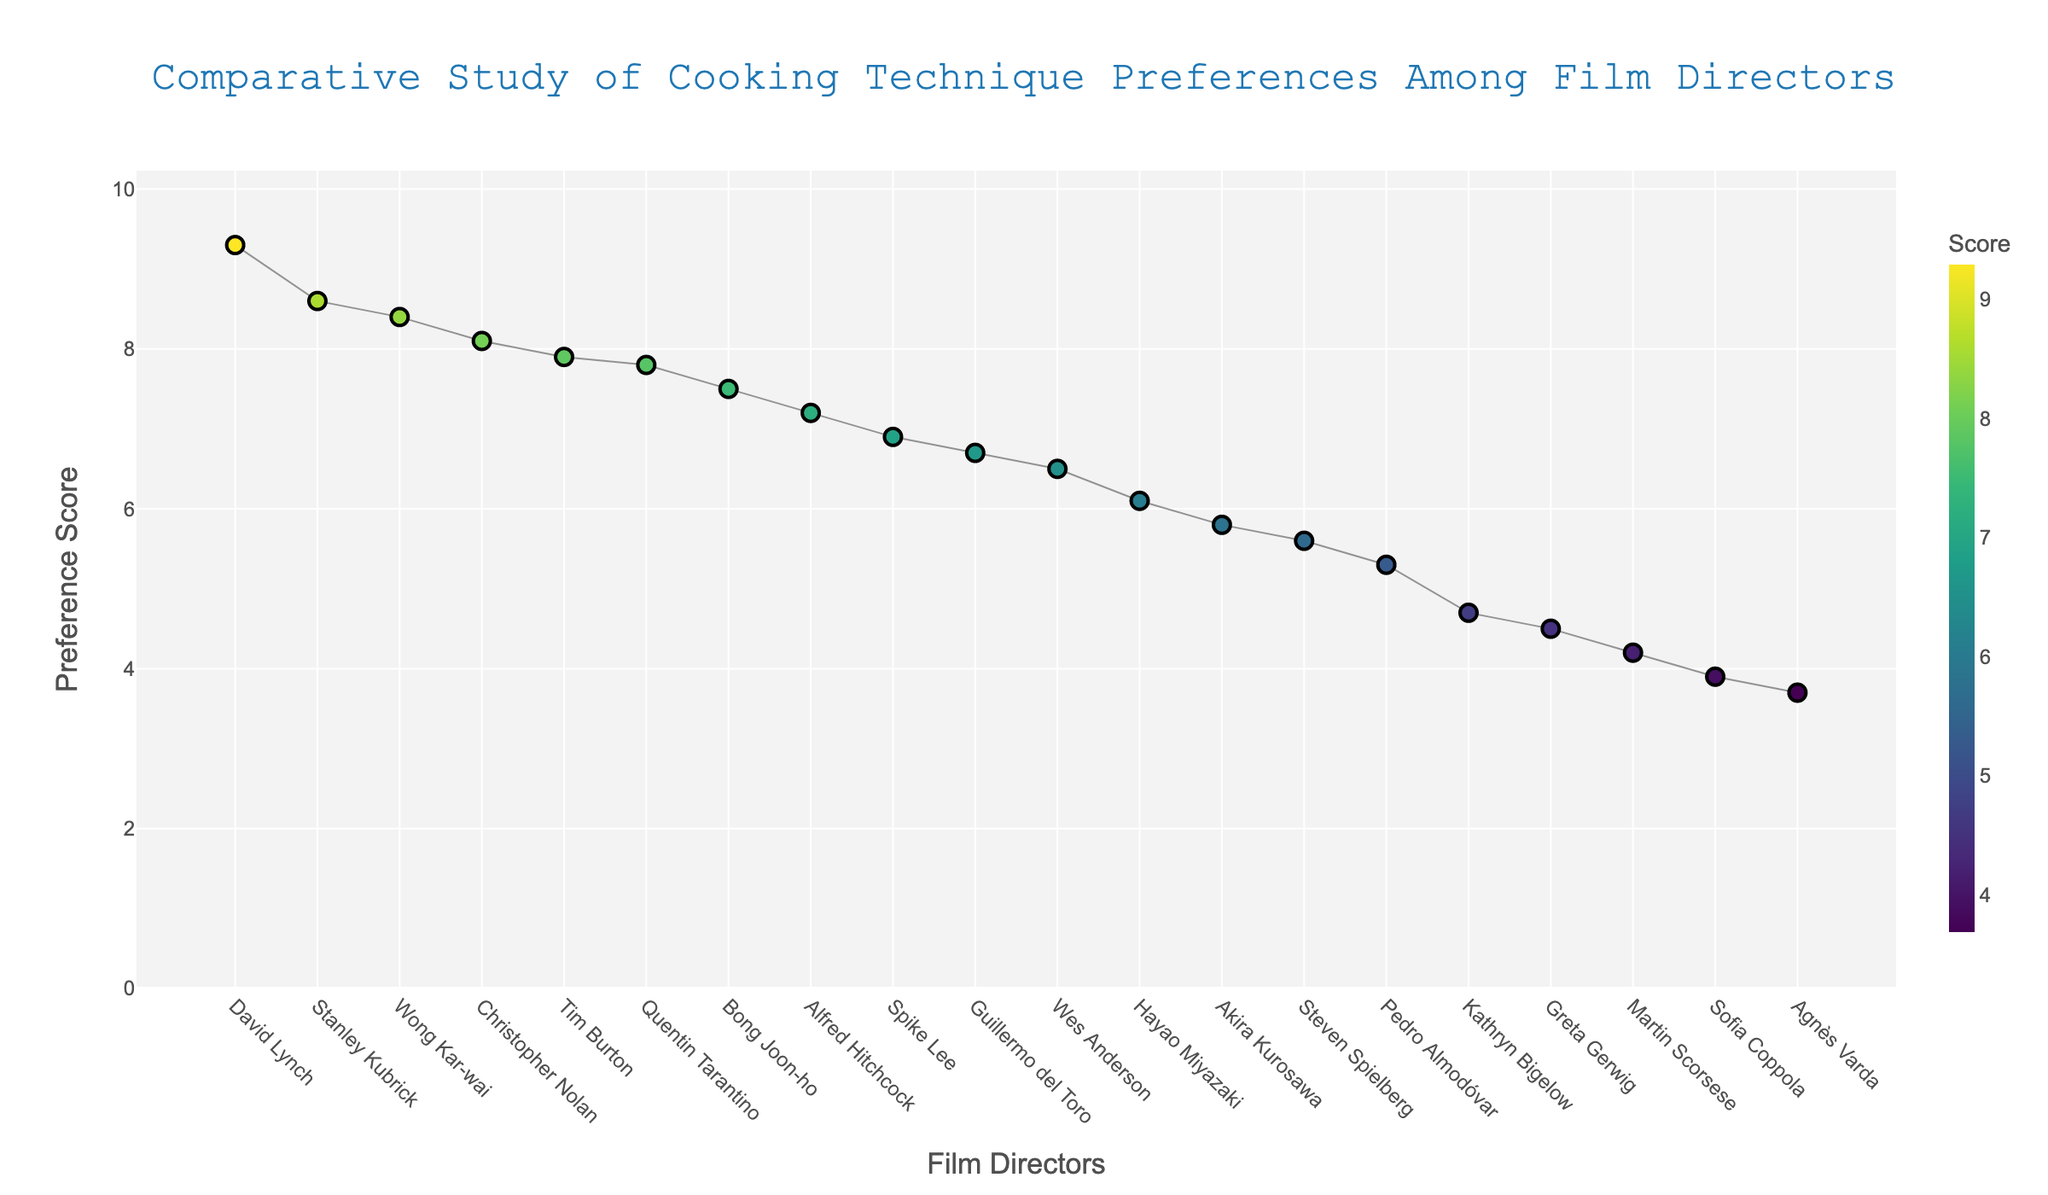What is the title of the plot? The title is displayed at the top center of the plot. It reads "Comparative Study of Cooking Technique Preferences Among Film Directors".
Answer: Comparative Study of Cooking Technique Preferences Among Film Directors Which film director has the highest preference score? The director with the highest point on the y-axis has the highest score. David Lynch, with Fermentation, scores the highest at 9.3.
Answer: David Lynch How many directors have a preference score above 8? The y-axis indicates preference scores. By counting the directors whose data points are above the 8-mark line, we observe there are 5 directors: Christopher Nolan, Stanley Kubrick, Wong Kar-wai, Tim Burton, and Quentin Tarantino.
Answer: 5 What is the average preference score for directors using Slow cooking, Grilling, Smoking, and Stir-frying? Retrieve the scores: Slow cooking (4.2), Grilling (5.6), Smoking (6.7), Stir-frying (5.8). Sum these scores: 4.2 + 5.6 + 6.7 + 5.8 = 22.3. Then divide by the number of items (4). 22.3 / 4 = 5.575.
Answer: 5.575 Which cooking technique shows the widest range of preference scores? Sort techniques based on the highest and lowest scores from the plot. The analysis shows that "Dehydration" by Stanley Kubrick scores 8.6 and "Poaching" by Sofia Coppola scores at 3.9, resulting in the widest gap.
Answer: Dehydration Which two directors have the closest preference scores? Compare nearby points visually. Hayao Miyazaki (Simmering, 6.1) and Akira Kurosawa (Stir-frying, 5.8) have scores very close to each other. The difference between 6.1 and 5.8 is 0.3.
Answer: Hayao Miyazaki and Akira Kurosawa Who has a higher preference score: Quentin Tarantino or Pedro Almodóvar? By how much? Find Quentin Tarantino's score (Flambé, 7.8) and Pedro Almodóvar's score (Pickling, 5.3) on the plot. The difference is 7.8 - 5.3 = 2.5.
Answer: Quentin Tarantino, by 2.5 What is the median preference score of all directors? Sort all scores and find the middle value. The median of 19 values (sorted) is the 10th value, which is Steven Spielberg (Grilling, 5.6).
Answer: 5.6 Which director has the lowest preference score, and what technique is associated with it? Locate the lowest point on the y-axis. Agnès Varda with Steaming has the lowest score of 3.7.
Answer: Agnès Varda with Steaming What is the color scale indicating on the plot? The color scale corresponds to the preference scores, from lower (darker) to higher (lighter) gradient colors.
Answer: Preference scores 